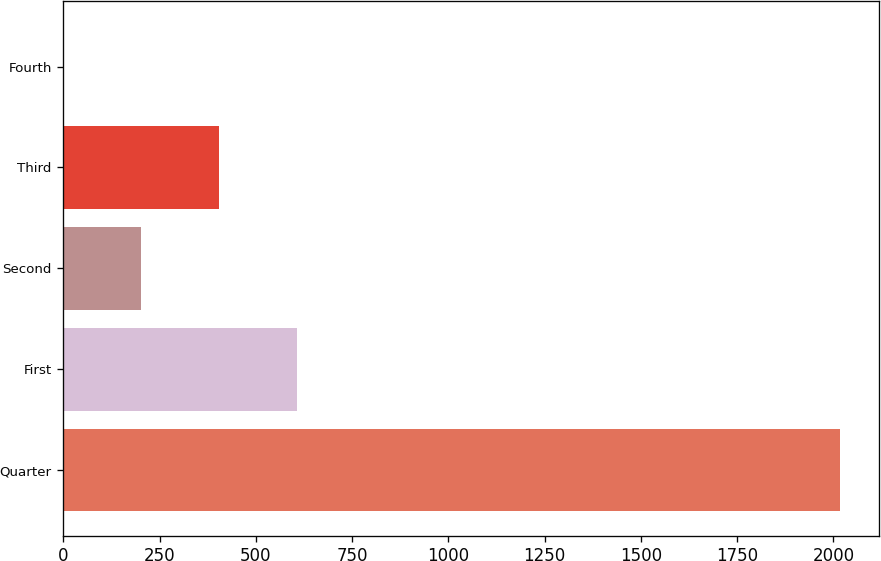<chart> <loc_0><loc_0><loc_500><loc_500><bar_chart><fcel>Quarter<fcel>First<fcel>Second<fcel>Third<fcel>Fourth<nl><fcel>2017<fcel>605.46<fcel>202.16<fcel>403.81<fcel>0.51<nl></chart> 